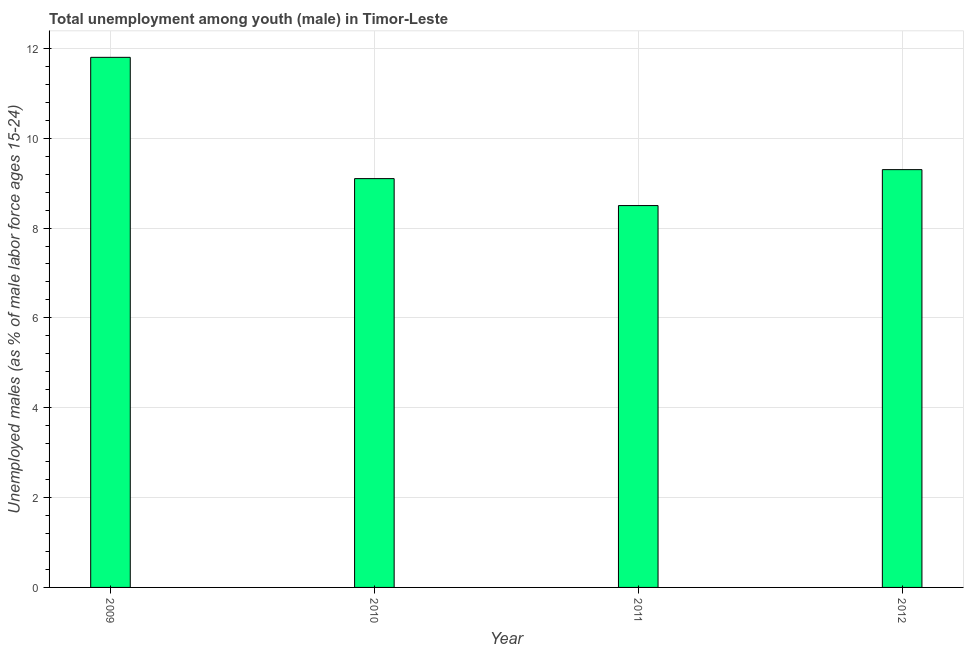What is the title of the graph?
Your answer should be very brief. Total unemployment among youth (male) in Timor-Leste. What is the label or title of the Y-axis?
Provide a short and direct response. Unemployed males (as % of male labor force ages 15-24). Across all years, what is the maximum unemployed male youth population?
Your answer should be very brief. 11.8. In which year was the unemployed male youth population minimum?
Your answer should be compact. 2011. What is the sum of the unemployed male youth population?
Keep it short and to the point. 38.7. What is the average unemployed male youth population per year?
Provide a succinct answer. 9.68. What is the median unemployed male youth population?
Provide a succinct answer. 9.2. Do a majority of the years between 2011 and 2010 (inclusive) have unemployed male youth population greater than 1.2 %?
Give a very brief answer. No. What is the ratio of the unemployed male youth population in 2010 to that in 2011?
Give a very brief answer. 1.07. What is the difference between the highest and the second highest unemployed male youth population?
Provide a succinct answer. 2.5. What is the difference between the highest and the lowest unemployed male youth population?
Offer a very short reply. 3.3. How many bars are there?
Your response must be concise. 4. What is the difference between two consecutive major ticks on the Y-axis?
Offer a very short reply. 2. What is the Unemployed males (as % of male labor force ages 15-24) in 2009?
Give a very brief answer. 11.8. What is the Unemployed males (as % of male labor force ages 15-24) in 2010?
Offer a very short reply. 9.1. What is the Unemployed males (as % of male labor force ages 15-24) of 2011?
Keep it short and to the point. 8.5. What is the Unemployed males (as % of male labor force ages 15-24) in 2012?
Offer a terse response. 9.3. What is the difference between the Unemployed males (as % of male labor force ages 15-24) in 2010 and 2011?
Offer a terse response. 0.6. What is the ratio of the Unemployed males (as % of male labor force ages 15-24) in 2009 to that in 2010?
Provide a succinct answer. 1.3. What is the ratio of the Unemployed males (as % of male labor force ages 15-24) in 2009 to that in 2011?
Offer a terse response. 1.39. What is the ratio of the Unemployed males (as % of male labor force ages 15-24) in 2009 to that in 2012?
Offer a terse response. 1.27. What is the ratio of the Unemployed males (as % of male labor force ages 15-24) in 2010 to that in 2011?
Your response must be concise. 1.07. What is the ratio of the Unemployed males (as % of male labor force ages 15-24) in 2010 to that in 2012?
Give a very brief answer. 0.98. What is the ratio of the Unemployed males (as % of male labor force ages 15-24) in 2011 to that in 2012?
Give a very brief answer. 0.91. 